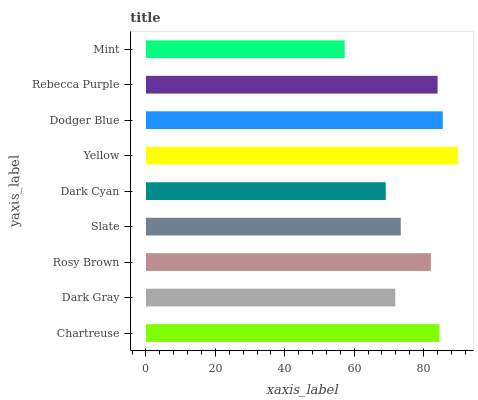Is Mint the minimum?
Answer yes or no. Yes. Is Yellow the maximum?
Answer yes or no. Yes. Is Dark Gray the minimum?
Answer yes or no. No. Is Dark Gray the maximum?
Answer yes or no. No. Is Chartreuse greater than Dark Gray?
Answer yes or no. Yes. Is Dark Gray less than Chartreuse?
Answer yes or no. Yes. Is Dark Gray greater than Chartreuse?
Answer yes or no. No. Is Chartreuse less than Dark Gray?
Answer yes or no. No. Is Rosy Brown the high median?
Answer yes or no. Yes. Is Rosy Brown the low median?
Answer yes or no. Yes. Is Slate the high median?
Answer yes or no. No. Is Chartreuse the low median?
Answer yes or no. No. 